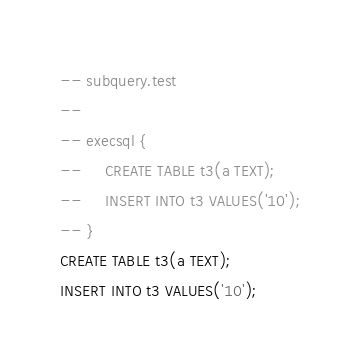Convert code to text. <code><loc_0><loc_0><loc_500><loc_500><_SQL_>-- subquery.test
-- 
-- execsql {
--     CREATE TABLE t3(a TEXT);
--     INSERT INTO t3 VALUES('10');
-- }
CREATE TABLE t3(a TEXT);
INSERT INTO t3 VALUES('10');</code> 